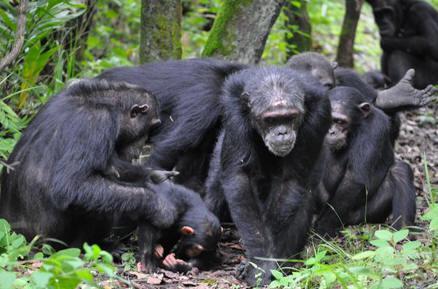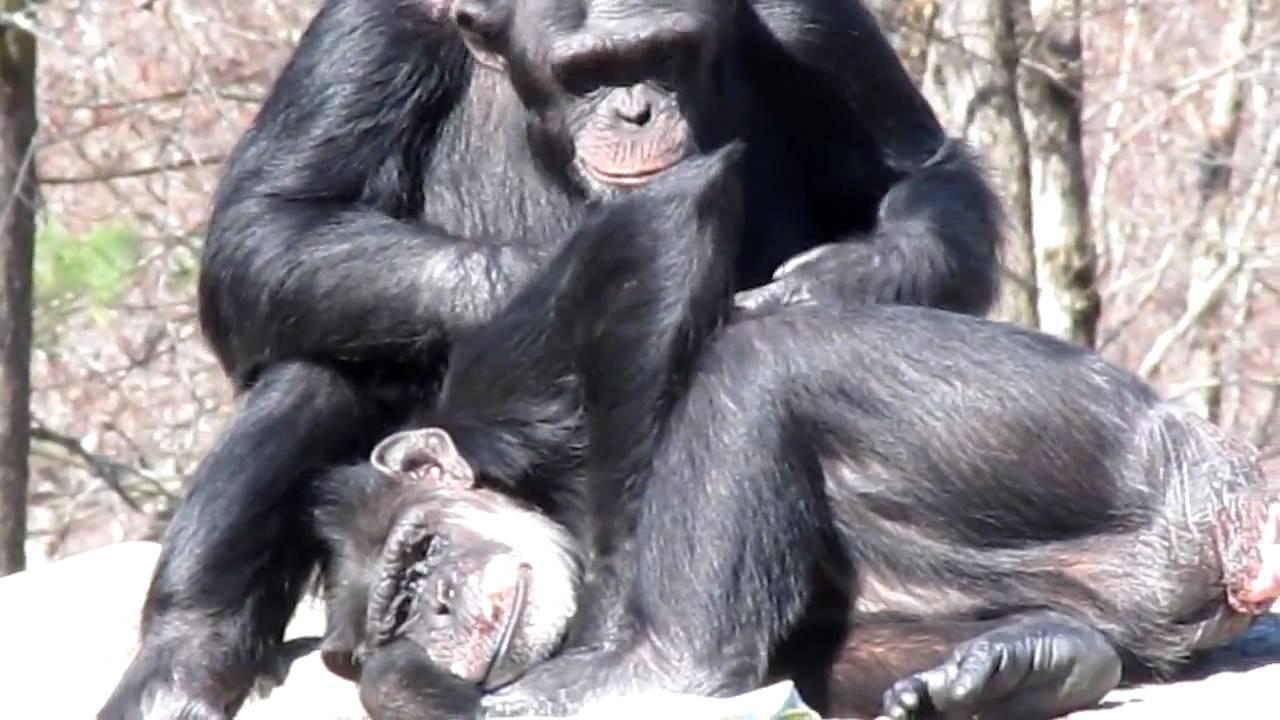The first image is the image on the left, the second image is the image on the right. Evaluate the accuracy of this statement regarding the images: "There are exactly three gorillas huddled together in the image on the left.". Is it true? Answer yes or no. No. The first image is the image on the left, the second image is the image on the right. For the images shown, is this caption "An image shows two rightward-facing apes, with one sitting behind the other." true? Answer yes or no. No. 